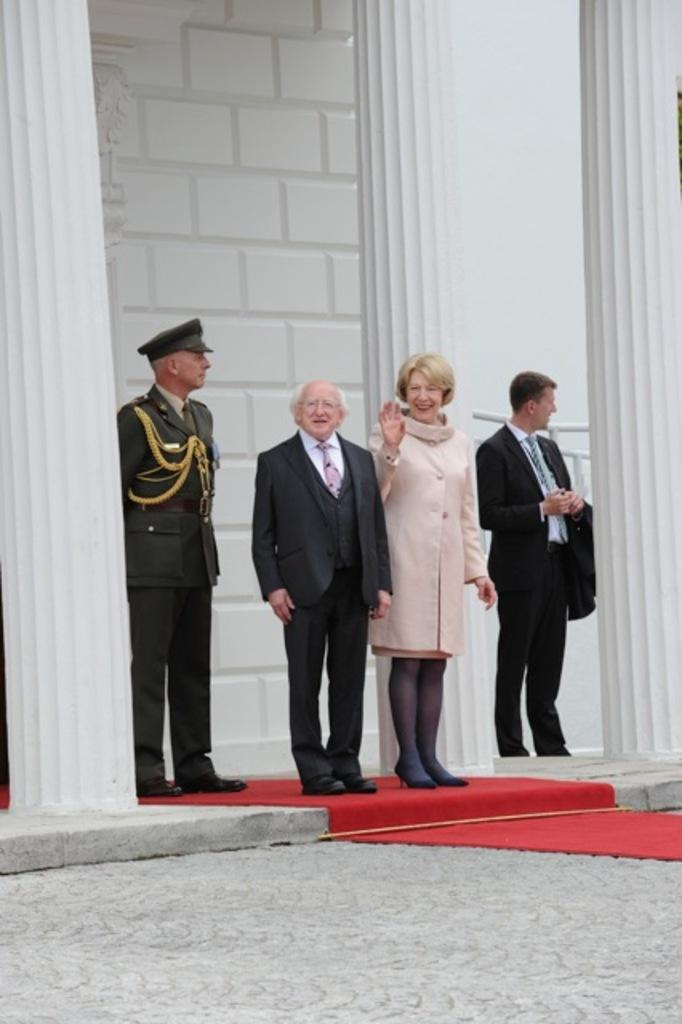What is happening in the image? There are people standing in the image. Can you describe the clothing of one of the individuals? The man on the left is wearing a uniform. What is at the bottom of the image? There is a red carpet at the bottom of the image. What can be seen in the background of the image? There is a building in the background of the image. Are there any cacti visible on the red carpet in the image? No, there are no cacti present in the image. What type of oatmeal is being served at the event in the image? There is no mention of oatmeal or any event in the image. 